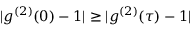Convert formula to latex. <formula><loc_0><loc_0><loc_500><loc_500>| g ^ { ( 2 ) } ( 0 ) - 1 | \geq | g ^ { ( 2 ) } ( \tau ) - 1 |</formula> 